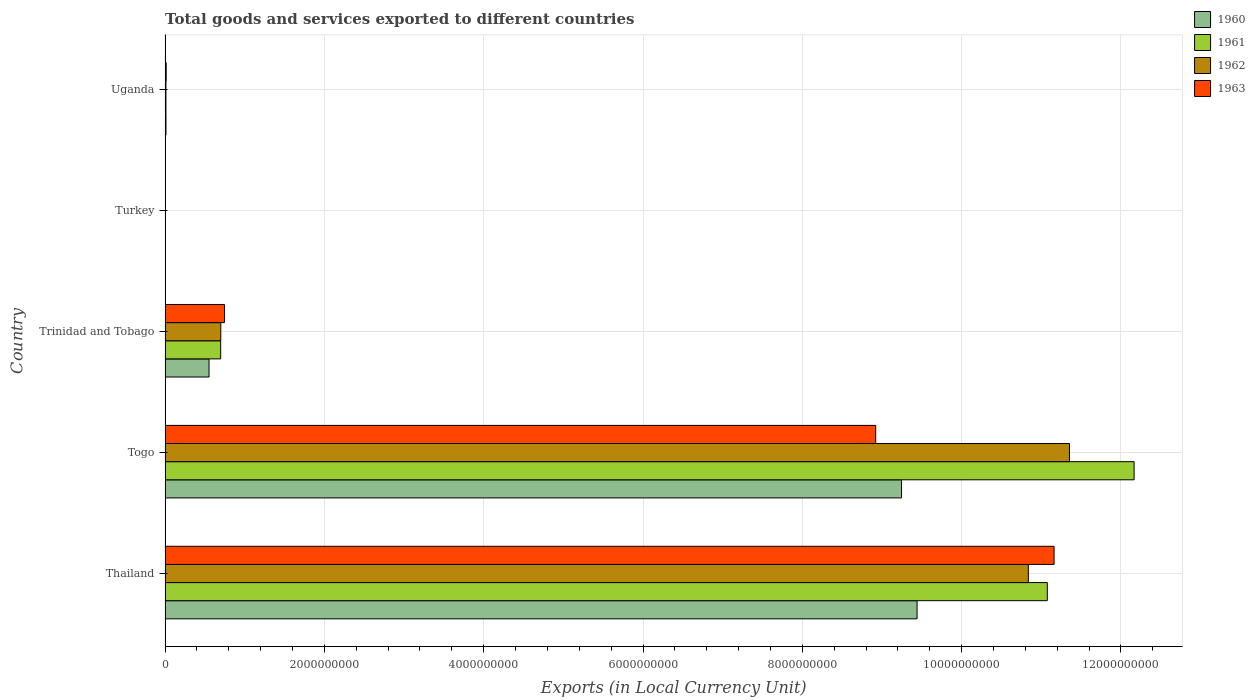How many different coloured bars are there?
Your answer should be compact. 4. Are the number of bars per tick equal to the number of legend labels?
Offer a terse response. Yes. How many bars are there on the 4th tick from the bottom?
Offer a very short reply. 4. What is the label of the 1st group of bars from the top?
Offer a terse response. Uganda. What is the Amount of goods and services exports in 1963 in Trinidad and Tobago?
Make the answer very short. 7.46e+08. Across all countries, what is the maximum Amount of goods and services exports in 1963?
Offer a very short reply. 1.12e+1. Across all countries, what is the minimum Amount of goods and services exports in 1963?
Provide a succinct answer. 3900. In which country was the Amount of goods and services exports in 1963 maximum?
Keep it short and to the point. Thailand. What is the total Amount of goods and services exports in 1960 in the graph?
Ensure brevity in your answer.  1.92e+1. What is the difference between the Amount of goods and services exports in 1960 in Trinidad and Tobago and that in Turkey?
Ensure brevity in your answer.  5.52e+08. What is the difference between the Amount of goods and services exports in 1963 in Thailand and the Amount of goods and services exports in 1961 in Trinidad and Tobago?
Your answer should be very brief. 1.05e+1. What is the average Amount of goods and services exports in 1963 per country?
Ensure brevity in your answer.  4.17e+09. What is the difference between the Amount of goods and services exports in 1961 and Amount of goods and services exports in 1962 in Togo?
Your answer should be compact. 8.11e+08. What is the ratio of the Amount of goods and services exports in 1961 in Thailand to that in Togo?
Offer a terse response. 0.91. What is the difference between the highest and the second highest Amount of goods and services exports in 1961?
Your answer should be compact. 1.09e+09. What is the difference between the highest and the lowest Amount of goods and services exports in 1961?
Give a very brief answer. 1.22e+1. What does the 1st bar from the top in Turkey represents?
Provide a succinct answer. 1963. How many countries are there in the graph?
Offer a terse response. 5. Does the graph contain grids?
Give a very brief answer. Yes. How are the legend labels stacked?
Offer a very short reply. Vertical. What is the title of the graph?
Your response must be concise. Total goods and services exported to different countries. Does "1970" appear as one of the legend labels in the graph?
Ensure brevity in your answer.  No. What is the label or title of the X-axis?
Your response must be concise. Exports (in Local Currency Unit). What is the Exports (in Local Currency Unit) of 1960 in Thailand?
Ensure brevity in your answer.  9.44e+09. What is the Exports (in Local Currency Unit) of 1961 in Thailand?
Provide a succinct answer. 1.11e+1. What is the Exports (in Local Currency Unit) in 1962 in Thailand?
Your response must be concise. 1.08e+1. What is the Exports (in Local Currency Unit) in 1963 in Thailand?
Make the answer very short. 1.12e+1. What is the Exports (in Local Currency Unit) of 1960 in Togo?
Offer a very short reply. 9.25e+09. What is the Exports (in Local Currency Unit) in 1961 in Togo?
Offer a terse response. 1.22e+1. What is the Exports (in Local Currency Unit) in 1962 in Togo?
Make the answer very short. 1.14e+1. What is the Exports (in Local Currency Unit) of 1963 in Togo?
Make the answer very short. 8.92e+09. What is the Exports (in Local Currency Unit) in 1960 in Trinidad and Tobago?
Offer a terse response. 5.52e+08. What is the Exports (in Local Currency Unit) in 1961 in Trinidad and Tobago?
Provide a short and direct response. 6.98e+08. What is the Exports (in Local Currency Unit) in 1962 in Trinidad and Tobago?
Your answer should be compact. 6.99e+08. What is the Exports (in Local Currency Unit) of 1963 in Trinidad and Tobago?
Your answer should be very brief. 7.46e+08. What is the Exports (in Local Currency Unit) in 1960 in Turkey?
Give a very brief answer. 1400. What is the Exports (in Local Currency Unit) of 1961 in Turkey?
Give a very brief answer. 3700. What is the Exports (in Local Currency Unit) of 1962 in Turkey?
Offer a terse response. 4500. What is the Exports (in Local Currency Unit) in 1963 in Turkey?
Make the answer very short. 3900. What is the Exports (in Local Currency Unit) in 1960 in Uganda?
Make the answer very short. 1.10e+07. What is the Exports (in Local Currency Unit) in 1961 in Uganda?
Offer a terse response. 1.03e+07. What is the Exports (in Local Currency Unit) of 1962 in Uganda?
Your response must be concise. 1.03e+07. What is the Exports (in Local Currency Unit) in 1963 in Uganda?
Offer a terse response. 1.39e+07. Across all countries, what is the maximum Exports (in Local Currency Unit) in 1960?
Your answer should be compact. 9.44e+09. Across all countries, what is the maximum Exports (in Local Currency Unit) in 1961?
Provide a succinct answer. 1.22e+1. Across all countries, what is the maximum Exports (in Local Currency Unit) of 1962?
Provide a succinct answer. 1.14e+1. Across all countries, what is the maximum Exports (in Local Currency Unit) in 1963?
Make the answer very short. 1.12e+1. Across all countries, what is the minimum Exports (in Local Currency Unit) in 1960?
Your response must be concise. 1400. Across all countries, what is the minimum Exports (in Local Currency Unit) of 1961?
Provide a short and direct response. 3700. Across all countries, what is the minimum Exports (in Local Currency Unit) of 1962?
Provide a succinct answer. 4500. Across all countries, what is the minimum Exports (in Local Currency Unit) in 1963?
Ensure brevity in your answer.  3900. What is the total Exports (in Local Currency Unit) of 1960 in the graph?
Offer a terse response. 1.92e+1. What is the total Exports (in Local Currency Unit) of 1961 in the graph?
Provide a succinct answer. 2.39e+1. What is the total Exports (in Local Currency Unit) in 1962 in the graph?
Make the answer very short. 2.29e+1. What is the total Exports (in Local Currency Unit) in 1963 in the graph?
Your answer should be compact. 2.08e+1. What is the difference between the Exports (in Local Currency Unit) in 1960 in Thailand and that in Togo?
Offer a terse response. 1.95e+08. What is the difference between the Exports (in Local Currency Unit) of 1961 in Thailand and that in Togo?
Give a very brief answer. -1.09e+09. What is the difference between the Exports (in Local Currency Unit) of 1962 in Thailand and that in Togo?
Your response must be concise. -5.17e+08. What is the difference between the Exports (in Local Currency Unit) in 1963 in Thailand and that in Togo?
Your answer should be compact. 2.24e+09. What is the difference between the Exports (in Local Currency Unit) of 1960 in Thailand and that in Trinidad and Tobago?
Provide a succinct answer. 8.89e+09. What is the difference between the Exports (in Local Currency Unit) in 1961 in Thailand and that in Trinidad and Tobago?
Provide a short and direct response. 1.04e+1. What is the difference between the Exports (in Local Currency Unit) in 1962 in Thailand and that in Trinidad and Tobago?
Give a very brief answer. 1.01e+1. What is the difference between the Exports (in Local Currency Unit) of 1963 in Thailand and that in Trinidad and Tobago?
Offer a terse response. 1.04e+1. What is the difference between the Exports (in Local Currency Unit) of 1960 in Thailand and that in Turkey?
Provide a short and direct response. 9.44e+09. What is the difference between the Exports (in Local Currency Unit) of 1961 in Thailand and that in Turkey?
Your answer should be compact. 1.11e+1. What is the difference between the Exports (in Local Currency Unit) of 1962 in Thailand and that in Turkey?
Keep it short and to the point. 1.08e+1. What is the difference between the Exports (in Local Currency Unit) in 1963 in Thailand and that in Turkey?
Provide a short and direct response. 1.12e+1. What is the difference between the Exports (in Local Currency Unit) in 1960 in Thailand and that in Uganda?
Keep it short and to the point. 9.43e+09. What is the difference between the Exports (in Local Currency Unit) in 1961 in Thailand and that in Uganda?
Ensure brevity in your answer.  1.11e+1. What is the difference between the Exports (in Local Currency Unit) in 1962 in Thailand and that in Uganda?
Give a very brief answer. 1.08e+1. What is the difference between the Exports (in Local Currency Unit) of 1963 in Thailand and that in Uganda?
Provide a short and direct response. 1.11e+1. What is the difference between the Exports (in Local Currency Unit) of 1960 in Togo and that in Trinidad and Tobago?
Provide a succinct answer. 8.69e+09. What is the difference between the Exports (in Local Currency Unit) of 1961 in Togo and that in Trinidad and Tobago?
Ensure brevity in your answer.  1.15e+1. What is the difference between the Exports (in Local Currency Unit) of 1962 in Togo and that in Trinidad and Tobago?
Ensure brevity in your answer.  1.07e+1. What is the difference between the Exports (in Local Currency Unit) of 1963 in Togo and that in Trinidad and Tobago?
Provide a short and direct response. 8.18e+09. What is the difference between the Exports (in Local Currency Unit) in 1960 in Togo and that in Turkey?
Ensure brevity in your answer.  9.25e+09. What is the difference between the Exports (in Local Currency Unit) of 1961 in Togo and that in Turkey?
Provide a succinct answer. 1.22e+1. What is the difference between the Exports (in Local Currency Unit) of 1962 in Togo and that in Turkey?
Your answer should be compact. 1.14e+1. What is the difference between the Exports (in Local Currency Unit) of 1963 in Togo and that in Turkey?
Make the answer very short. 8.92e+09. What is the difference between the Exports (in Local Currency Unit) of 1960 in Togo and that in Uganda?
Your answer should be compact. 9.23e+09. What is the difference between the Exports (in Local Currency Unit) in 1961 in Togo and that in Uganda?
Offer a terse response. 1.22e+1. What is the difference between the Exports (in Local Currency Unit) of 1962 in Togo and that in Uganda?
Your answer should be very brief. 1.13e+1. What is the difference between the Exports (in Local Currency Unit) of 1963 in Togo and that in Uganda?
Your response must be concise. 8.91e+09. What is the difference between the Exports (in Local Currency Unit) of 1960 in Trinidad and Tobago and that in Turkey?
Ensure brevity in your answer.  5.52e+08. What is the difference between the Exports (in Local Currency Unit) of 1961 in Trinidad and Tobago and that in Turkey?
Keep it short and to the point. 6.98e+08. What is the difference between the Exports (in Local Currency Unit) of 1962 in Trinidad and Tobago and that in Turkey?
Provide a short and direct response. 6.99e+08. What is the difference between the Exports (in Local Currency Unit) of 1963 in Trinidad and Tobago and that in Turkey?
Your response must be concise. 7.46e+08. What is the difference between the Exports (in Local Currency Unit) in 1960 in Trinidad and Tobago and that in Uganda?
Offer a terse response. 5.41e+08. What is the difference between the Exports (in Local Currency Unit) in 1961 in Trinidad and Tobago and that in Uganda?
Your response must be concise. 6.87e+08. What is the difference between the Exports (in Local Currency Unit) of 1962 in Trinidad and Tobago and that in Uganda?
Provide a short and direct response. 6.89e+08. What is the difference between the Exports (in Local Currency Unit) of 1963 in Trinidad and Tobago and that in Uganda?
Provide a succinct answer. 7.32e+08. What is the difference between the Exports (in Local Currency Unit) in 1960 in Turkey and that in Uganda?
Keep it short and to the point. -1.10e+07. What is the difference between the Exports (in Local Currency Unit) in 1961 in Turkey and that in Uganda?
Provide a short and direct response. -1.03e+07. What is the difference between the Exports (in Local Currency Unit) of 1962 in Turkey and that in Uganda?
Provide a succinct answer. -1.03e+07. What is the difference between the Exports (in Local Currency Unit) of 1963 in Turkey and that in Uganda?
Your answer should be very brief. -1.39e+07. What is the difference between the Exports (in Local Currency Unit) in 1960 in Thailand and the Exports (in Local Currency Unit) in 1961 in Togo?
Your answer should be compact. -2.72e+09. What is the difference between the Exports (in Local Currency Unit) in 1960 in Thailand and the Exports (in Local Currency Unit) in 1962 in Togo?
Offer a very short reply. -1.91e+09. What is the difference between the Exports (in Local Currency Unit) in 1960 in Thailand and the Exports (in Local Currency Unit) in 1963 in Togo?
Provide a short and direct response. 5.19e+08. What is the difference between the Exports (in Local Currency Unit) of 1961 in Thailand and the Exports (in Local Currency Unit) of 1962 in Togo?
Give a very brief answer. -2.79e+08. What is the difference between the Exports (in Local Currency Unit) in 1961 in Thailand and the Exports (in Local Currency Unit) in 1963 in Togo?
Offer a terse response. 2.15e+09. What is the difference between the Exports (in Local Currency Unit) of 1962 in Thailand and the Exports (in Local Currency Unit) of 1963 in Togo?
Make the answer very short. 1.92e+09. What is the difference between the Exports (in Local Currency Unit) in 1960 in Thailand and the Exports (in Local Currency Unit) in 1961 in Trinidad and Tobago?
Your response must be concise. 8.74e+09. What is the difference between the Exports (in Local Currency Unit) in 1960 in Thailand and the Exports (in Local Currency Unit) in 1962 in Trinidad and Tobago?
Keep it short and to the point. 8.74e+09. What is the difference between the Exports (in Local Currency Unit) of 1960 in Thailand and the Exports (in Local Currency Unit) of 1963 in Trinidad and Tobago?
Offer a terse response. 8.69e+09. What is the difference between the Exports (in Local Currency Unit) of 1961 in Thailand and the Exports (in Local Currency Unit) of 1962 in Trinidad and Tobago?
Keep it short and to the point. 1.04e+1. What is the difference between the Exports (in Local Currency Unit) in 1961 in Thailand and the Exports (in Local Currency Unit) in 1963 in Trinidad and Tobago?
Your answer should be very brief. 1.03e+1. What is the difference between the Exports (in Local Currency Unit) of 1962 in Thailand and the Exports (in Local Currency Unit) of 1963 in Trinidad and Tobago?
Give a very brief answer. 1.01e+1. What is the difference between the Exports (in Local Currency Unit) in 1960 in Thailand and the Exports (in Local Currency Unit) in 1961 in Turkey?
Your response must be concise. 9.44e+09. What is the difference between the Exports (in Local Currency Unit) of 1960 in Thailand and the Exports (in Local Currency Unit) of 1962 in Turkey?
Offer a very short reply. 9.44e+09. What is the difference between the Exports (in Local Currency Unit) of 1960 in Thailand and the Exports (in Local Currency Unit) of 1963 in Turkey?
Make the answer very short. 9.44e+09. What is the difference between the Exports (in Local Currency Unit) of 1961 in Thailand and the Exports (in Local Currency Unit) of 1962 in Turkey?
Offer a very short reply. 1.11e+1. What is the difference between the Exports (in Local Currency Unit) of 1961 in Thailand and the Exports (in Local Currency Unit) of 1963 in Turkey?
Provide a succinct answer. 1.11e+1. What is the difference between the Exports (in Local Currency Unit) of 1962 in Thailand and the Exports (in Local Currency Unit) of 1963 in Turkey?
Provide a short and direct response. 1.08e+1. What is the difference between the Exports (in Local Currency Unit) of 1960 in Thailand and the Exports (in Local Currency Unit) of 1961 in Uganda?
Your answer should be compact. 9.43e+09. What is the difference between the Exports (in Local Currency Unit) of 1960 in Thailand and the Exports (in Local Currency Unit) of 1962 in Uganda?
Make the answer very short. 9.43e+09. What is the difference between the Exports (in Local Currency Unit) in 1960 in Thailand and the Exports (in Local Currency Unit) in 1963 in Uganda?
Provide a short and direct response. 9.43e+09. What is the difference between the Exports (in Local Currency Unit) of 1961 in Thailand and the Exports (in Local Currency Unit) of 1962 in Uganda?
Your response must be concise. 1.11e+1. What is the difference between the Exports (in Local Currency Unit) in 1961 in Thailand and the Exports (in Local Currency Unit) in 1963 in Uganda?
Provide a short and direct response. 1.11e+1. What is the difference between the Exports (in Local Currency Unit) in 1962 in Thailand and the Exports (in Local Currency Unit) in 1963 in Uganda?
Your answer should be compact. 1.08e+1. What is the difference between the Exports (in Local Currency Unit) in 1960 in Togo and the Exports (in Local Currency Unit) in 1961 in Trinidad and Tobago?
Your answer should be compact. 8.55e+09. What is the difference between the Exports (in Local Currency Unit) of 1960 in Togo and the Exports (in Local Currency Unit) of 1962 in Trinidad and Tobago?
Offer a very short reply. 8.55e+09. What is the difference between the Exports (in Local Currency Unit) in 1960 in Togo and the Exports (in Local Currency Unit) in 1963 in Trinidad and Tobago?
Your answer should be compact. 8.50e+09. What is the difference between the Exports (in Local Currency Unit) of 1961 in Togo and the Exports (in Local Currency Unit) of 1962 in Trinidad and Tobago?
Offer a terse response. 1.15e+1. What is the difference between the Exports (in Local Currency Unit) of 1961 in Togo and the Exports (in Local Currency Unit) of 1963 in Trinidad and Tobago?
Provide a short and direct response. 1.14e+1. What is the difference between the Exports (in Local Currency Unit) in 1962 in Togo and the Exports (in Local Currency Unit) in 1963 in Trinidad and Tobago?
Keep it short and to the point. 1.06e+1. What is the difference between the Exports (in Local Currency Unit) in 1960 in Togo and the Exports (in Local Currency Unit) in 1961 in Turkey?
Keep it short and to the point. 9.25e+09. What is the difference between the Exports (in Local Currency Unit) in 1960 in Togo and the Exports (in Local Currency Unit) in 1962 in Turkey?
Offer a very short reply. 9.25e+09. What is the difference between the Exports (in Local Currency Unit) in 1960 in Togo and the Exports (in Local Currency Unit) in 1963 in Turkey?
Offer a very short reply. 9.25e+09. What is the difference between the Exports (in Local Currency Unit) in 1961 in Togo and the Exports (in Local Currency Unit) in 1962 in Turkey?
Provide a succinct answer. 1.22e+1. What is the difference between the Exports (in Local Currency Unit) in 1961 in Togo and the Exports (in Local Currency Unit) in 1963 in Turkey?
Keep it short and to the point. 1.22e+1. What is the difference between the Exports (in Local Currency Unit) in 1962 in Togo and the Exports (in Local Currency Unit) in 1963 in Turkey?
Provide a succinct answer. 1.14e+1. What is the difference between the Exports (in Local Currency Unit) in 1960 in Togo and the Exports (in Local Currency Unit) in 1961 in Uganda?
Your answer should be compact. 9.24e+09. What is the difference between the Exports (in Local Currency Unit) of 1960 in Togo and the Exports (in Local Currency Unit) of 1962 in Uganda?
Your response must be concise. 9.24e+09. What is the difference between the Exports (in Local Currency Unit) in 1960 in Togo and the Exports (in Local Currency Unit) in 1963 in Uganda?
Provide a succinct answer. 9.23e+09. What is the difference between the Exports (in Local Currency Unit) of 1961 in Togo and the Exports (in Local Currency Unit) of 1962 in Uganda?
Offer a terse response. 1.22e+1. What is the difference between the Exports (in Local Currency Unit) of 1961 in Togo and the Exports (in Local Currency Unit) of 1963 in Uganda?
Ensure brevity in your answer.  1.22e+1. What is the difference between the Exports (in Local Currency Unit) of 1962 in Togo and the Exports (in Local Currency Unit) of 1963 in Uganda?
Ensure brevity in your answer.  1.13e+1. What is the difference between the Exports (in Local Currency Unit) of 1960 in Trinidad and Tobago and the Exports (in Local Currency Unit) of 1961 in Turkey?
Offer a terse response. 5.52e+08. What is the difference between the Exports (in Local Currency Unit) in 1960 in Trinidad and Tobago and the Exports (in Local Currency Unit) in 1962 in Turkey?
Your response must be concise. 5.52e+08. What is the difference between the Exports (in Local Currency Unit) in 1960 in Trinidad and Tobago and the Exports (in Local Currency Unit) in 1963 in Turkey?
Make the answer very short. 5.52e+08. What is the difference between the Exports (in Local Currency Unit) in 1961 in Trinidad and Tobago and the Exports (in Local Currency Unit) in 1962 in Turkey?
Offer a very short reply. 6.98e+08. What is the difference between the Exports (in Local Currency Unit) of 1961 in Trinidad and Tobago and the Exports (in Local Currency Unit) of 1963 in Turkey?
Your response must be concise. 6.98e+08. What is the difference between the Exports (in Local Currency Unit) in 1962 in Trinidad and Tobago and the Exports (in Local Currency Unit) in 1963 in Turkey?
Provide a short and direct response. 6.99e+08. What is the difference between the Exports (in Local Currency Unit) in 1960 in Trinidad and Tobago and the Exports (in Local Currency Unit) in 1961 in Uganda?
Ensure brevity in your answer.  5.41e+08. What is the difference between the Exports (in Local Currency Unit) in 1960 in Trinidad and Tobago and the Exports (in Local Currency Unit) in 1962 in Uganda?
Your answer should be very brief. 5.41e+08. What is the difference between the Exports (in Local Currency Unit) of 1960 in Trinidad and Tobago and the Exports (in Local Currency Unit) of 1963 in Uganda?
Make the answer very short. 5.38e+08. What is the difference between the Exports (in Local Currency Unit) in 1961 in Trinidad and Tobago and the Exports (in Local Currency Unit) in 1962 in Uganda?
Ensure brevity in your answer.  6.87e+08. What is the difference between the Exports (in Local Currency Unit) in 1961 in Trinidad and Tobago and the Exports (in Local Currency Unit) in 1963 in Uganda?
Your answer should be very brief. 6.84e+08. What is the difference between the Exports (in Local Currency Unit) in 1962 in Trinidad and Tobago and the Exports (in Local Currency Unit) in 1963 in Uganda?
Your answer should be very brief. 6.85e+08. What is the difference between the Exports (in Local Currency Unit) in 1960 in Turkey and the Exports (in Local Currency Unit) in 1961 in Uganda?
Provide a short and direct response. -1.03e+07. What is the difference between the Exports (in Local Currency Unit) in 1960 in Turkey and the Exports (in Local Currency Unit) in 1962 in Uganda?
Provide a short and direct response. -1.03e+07. What is the difference between the Exports (in Local Currency Unit) in 1960 in Turkey and the Exports (in Local Currency Unit) in 1963 in Uganda?
Keep it short and to the point. -1.39e+07. What is the difference between the Exports (in Local Currency Unit) in 1961 in Turkey and the Exports (in Local Currency Unit) in 1962 in Uganda?
Offer a terse response. -1.03e+07. What is the difference between the Exports (in Local Currency Unit) of 1961 in Turkey and the Exports (in Local Currency Unit) of 1963 in Uganda?
Give a very brief answer. -1.39e+07. What is the difference between the Exports (in Local Currency Unit) in 1962 in Turkey and the Exports (in Local Currency Unit) in 1963 in Uganda?
Ensure brevity in your answer.  -1.39e+07. What is the average Exports (in Local Currency Unit) in 1960 per country?
Keep it short and to the point. 3.85e+09. What is the average Exports (in Local Currency Unit) in 1961 per country?
Offer a very short reply. 4.79e+09. What is the average Exports (in Local Currency Unit) of 1962 per country?
Your answer should be compact. 4.58e+09. What is the average Exports (in Local Currency Unit) in 1963 per country?
Give a very brief answer. 4.17e+09. What is the difference between the Exports (in Local Currency Unit) of 1960 and Exports (in Local Currency Unit) of 1961 in Thailand?
Offer a very short reply. -1.64e+09. What is the difference between the Exports (in Local Currency Unit) of 1960 and Exports (in Local Currency Unit) of 1962 in Thailand?
Make the answer very short. -1.40e+09. What is the difference between the Exports (in Local Currency Unit) of 1960 and Exports (in Local Currency Unit) of 1963 in Thailand?
Ensure brevity in your answer.  -1.72e+09. What is the difference between the Exports (in Local Currency Unit) of 1961 and Exports (in Local Currency Unit) of 1962 in Thailand?
Keep it short and to the point. 2.38e+08. What is the difference between the Exports (in Local Currency Unit) in 1961 and Exports (in Local Currency Unit) in 1963 in Thailand?
Give a very brief answer. -8.50e+07. What is the difference between the Exports (in Local Currency Unit) of 1962 and Exports (in Local Currency Unit) of 1963 in Thailand?
Offer a terse response. -3.23e+08. What is the difference between the Exports (in Local Currency Unit) of 1960 and Exports (in Local Currency Unit) of 1961 in Togo?
Give a very brief answer. -2.92e+09. What is the difference between the Exports (in Local Currency Unit) in 1960 and Exports (in Local Currency Unit) in 1962 in Togo?
Give a very brief answer. -2.11e+09. What is the difference between the Exports (in Local Currency Unit) of 1960 and Exports (in Local Currency Unit) of 1963 in Togo?
Make the answer very short. 3.24e+08. What is the difference between the Exports (in Local Currency Unit) in 1961 and Exports (in Local Currency Unit) in 1962 in Togo?
Give a very brief answer. 8.11e+08. What is the difference between the Exports (in Local Currency Unit) of 1961 and Exports (in Local Currency Unit) of 1963 in Togo?
Your response must be concise. 3.24e+09. What is the difference between the Exports (in Local Currency Unit) in 1962 and Exports (in Local Currency Unit) in 1963 in Togo?
Provide a succinct answer. 2.43e+09. What is the difference between the Exports (in Local Currency Unit) of 1960 and Exports (in Local Currency Unit) of 1961 in Trinidad and Tobago?
Ensure brevity in your answer.  -1.46e+08. What is the difference between the Exports (in Local Currency Unit) of 1960 and Exports (in Local Currency Unit) of 1962 in Trinidad and Tobago?
Provide a succinct answer. -1.47e+08. What is the difference between the Exports (in Local Currency Unit) of 1960 and Exports (in Local Currency Unit) of 1963 in Trinidad and Tobago?
Your answer should be compact. -1.94e+08. What is the difference between the Exports (in Local Currency Unit) in 1961 and Exports (in Local Currency Unit) in 1962 in Trinidad and Tobago?
Your response must be concise. -1.50e+06. What is the difference between the Exports (in Local Currency Unit) in 1961 and Exports (in Local Currency Unit) in 1963 in Trinidad and Tobago?
Provide a short and direct response. -4.84e+07. What is the difference between the Exports (in Local Currency Unit) of 1962 and Exports (in Local Currency Unit) of 1963 in Trinidad and Tobago?
Ensure brevity in your answer.  -4.69e+07. What is the difference between the Exports (in Local Currency Unit) in 1960 and Exports (in Local Currency Unit) in 1961 in Turkey?
Your answer should be compact. -2300. What is the difference between the Exports (in Local Currency Unit) in 1960 and Exports (in Local Currency Unit) in 1962 in Turkey?
Your answer should be compact. -3100. What is the difference between the Exports (in Local Currency Unit) of 1960 and Exports (in Local Currency Unit) of 1963 in Turkey?
Give a very brief answer. -2500. What is the difference between the Exports (in Local Currency Unit) in 1961 and Exports (in Local Currency Unit) in 1962 in Turkey?
Make the answer very short. -800. What is the difference between the Exports (in Local Currency Unit) of 1961 and Exports (in Local Currency Unit) of 1963 in Turkey?
Your response must be concise. -200. What is the difference between the Exports (in Local Currency Unit) of 1962 and Exports (in Local Currency Unit) of 1963 in Turkey?
Keep it short and to the point. 600. What is the difference between the Exports (in Local Currency Unit) of 1960 and Exports (in Local Currency Unit) of 1961 in Uganda?
Provide a succinct answer. 7.44e+05. What is the difference between the Exports (in Local Currency Unit) of 1960 and Exports (in Local Currency Unit) of 1962 in Uganda?
Offer a terse response. 7.02e+05. What is the difference between the Exports (in Local Currency Unit) of 1960 and Exports (in Local Currency Unit) of 1963 in Uganda?
Make the answer very short. -2.90e+06. What is the difference between the Exports (in Local Currency Unit) of 1961 and Exports (in Local Currency Unit) of 1962 in Uganda?
Keep it short and to the point. -4.13e+04. What is the difference between the Exports (in Local Currency Unit) in 1961 and Exports (in Local Currency Unit) in 1963 in Uganda?
Provide a short and direct response. -3.65e+06. What is the difference between the Exports (in Local Currency Unit) of 1962 and Exports (in Local Currency Unit) of 1963 in Uganda?
Your answer should be compact. -3.60e+06. What is the ratio of the Exports (in Local Currency Unit) in 1960 in Thailand to that in Togo?
Offer a terse response. 1.02. What is the ratio of the Exports (in Local Currency Unit) of 1961 in Thailand to that in Togo?
Provide a short and direct response. 0.91. What is the ratio of the Exports (in Local Currency Unit) of 1962 in Thailand to that in Togo?
Your response must be concise. 0.95. What is the ratio of the Exports (in Local Currency Unit) of 1963 in Thailand to that in Togo?
Provide a succinct answer. 1.25. What is the ratio of the Exports (in Local Currency Unit) of 1960 in Thailand to that in Trinidad and Tobago?
Make the answer very short. 17.11. What is the ratio of the Exports (in Local Currency Unit) in 1961 in Thailand to that in Trinidad and Tobago?
Your answer should be very brief. 15.88. What is the ratio of the Exports (in Local Currency Unit) of 1962 in Thailand to that in Trinidad and Tobago?
Give a very brief answer. 15.5. What is the ratio of the Exports (in Local Currency Unit) of 1963 in Thailand to that in Trinidad and Tobago?
Give a very brief answer. 14.96. What is the ratio of the Exports (in Local Currency Unit) in 1960 in Thailand to that in Turkey?
Your answer should be compact. 6.74e+06. What is the ratio of the Exports (in Local Currency Unit) of 1961 in Thailand to that in Turkey?
Keep it short and to the point. 2.99e+06. What is the ratio of the Exports (in Local Currency Unit) of 1962 in Thailand to that in Turkey?
Ensure brevity in your answer.  2.41e+06. What is the ratio of the Exports (in Local Currency Unit) in 1963 in Thailand to that in Turkey?
Offer a very short reply. 2.86e+06. What is the ratio of the Exports (in Local Currency Unit) of 1960 in Thailand to that in Uganda?
Your response must be concise. 856.03. What is the ratio of the Exports (in Local Currency Unit) in 1961 in Thailand to that in Uganda?
Your answer should be very brief. 1076.88. What is the ratio of the Exports (in Local Currency Unit) of 1962 in Thailand to that in Uganda?
Give a very brief answer. 1049.52. What is the ratio of the Exports (in Local Currency Unit) of 1963 in Thailand to that in Uganda?
Keep it short and to the point. 801.19. What is the ratio of the Exports (in Local Currency Unit) of 1960 in Togo to that in Trinidad and Tobago?
Your response must be concise. 16.76. What is the ratio of the Exports (in Local Currency Unit) in 1961 in Togo to that in Trinidad and Tobago?
Make the answer very short. 17.44. What is the ratio of the Exports (in Local Currency Unit) of 1962 in Togo to that in Trinidad and Tobago?
Ensure brevity in your answer.  16.24. What is the ratio of the Exports (in Local Currency Unit) of 1963 in Togo to that in Trinidad and Tobago?
Offer a terse response. 11.96. What is the ratio of the Exports (in Local Currency Unit) of 1960 in Togo to that in Turkey?
Provide a succinct answer. 6.60e+06. What is the ratio of the Exports (in Local Currency Unit) in 1961 in Togo to that in Turkey?
Offer a terse response. 3.29e+06. What is the ratio of the Exports (in Local Currency Unit) in 1962 in Togo to that in Turkey?
Keep it short and to the point. 2.52e+06. What is the ratio of the Exports (in Local Currency Unit) in 1963 in Togo to that in Turkey?
Give a very brief answer. 2.29e+06. What is the ratio of the Exports (in Local Currency Unit) of 1960 in Togo to that in Uganda?
Your answer should be compact. 838.35. What is the ratio of the Exports (in Local Currency Unit) in 1961 in Togo to that in Uganda?
Provide a short and direct response. 1182.83. What is the ratio of the Exports (in Local Currency Unit) of 1962 in Togo to that in Uganda?
Give a very brief answer. 1099.56. What is the ratio of the Exports (in Local Currency Unit) of 1963 in Togo to that in Uganda?
Provide a short and direct response. 640.43. What is the ratio of the Exports (in Local Currency Unit) of 1960 in Trinidad and Tobago to that in Turkey?
Ensure brevity in your answer.  3.94e+05. What is the ratio of the Exports (in Local Currency Unit) in 1961 in Trinidad and Tobago to that in Turkey?
Your answer should be very brief. 1.89e+05. What is the ratio of the Exports (in Local Currency Unit) of 1962 in Trinidad and Tobago to that in Turkey?
Give a very brief answer. 1.55e+05. What is the ratio of the Exports (in Local Currency Unit) of 1963 in Trinidad and Tobago to that in Turkey?
Your response must be concise. 1.91e+05. What is the ratio of the Exports (in Local Currency Unit) of 1960 in Trinidad and Tobago to that in Uganda?
Give a very brief answer. 50.02. What is the ratio of the Exports (in Local Currency Unit) of 1961 in Trinidad and Tobago to that in Uganda?
Your answer should be compact. 67.83. What is the ratio of the Exports (in Local Currency Unit) in 1962 in Trinidad and Tobago to that in Uganda?
Keep it short and to the point. 67.71. What is the ratio of the Exports (in Local Currency Unit) of 1963 in Trinidad and Tobago to that in Uganda?
Provide a short and direct response. 53.56. What is the difference between the highest and the second highest Exports (in Local Currency Unit) in 1960?
Ensure brevity in your answer.  1.95e+08. What is the difference between the highest and the second highest Exports (in Local Currency Unit) of 1961?
Offer a terse response. 1.09e+09. What is the difference between the highest and the second highest Exports (in Local Currency Unit) in 1962?
Provide a succinct answer. 5.17e+08. What is the difference between the highest and the second highest Exports (in Local Currency Unit) of 1963?
Give a very brief answer. 2.24e+09. What is the difference between the highest and the lowest Exports (in Local Currency Unit) of 1960?
Give a very brief answer. 9.44e+09. What is the difference between the highest and the lowest Exports (in Local Currency Unit) of 1961?
Offer a terse response. 1.22e+1. What is the difference between the highest and the lowest Exports (in Local Currency Unit) of 1962?
Offer a very short reply. 1.14e+1. What is the difference between the highest and the lowest Exports (in Local Currency Unit) in 1963?
Keep it short and to the point. 1.12e+1. 